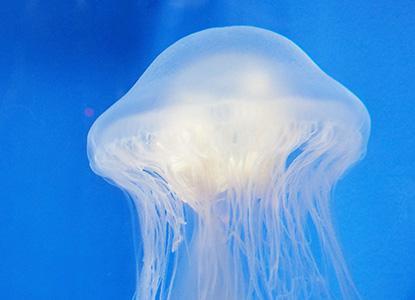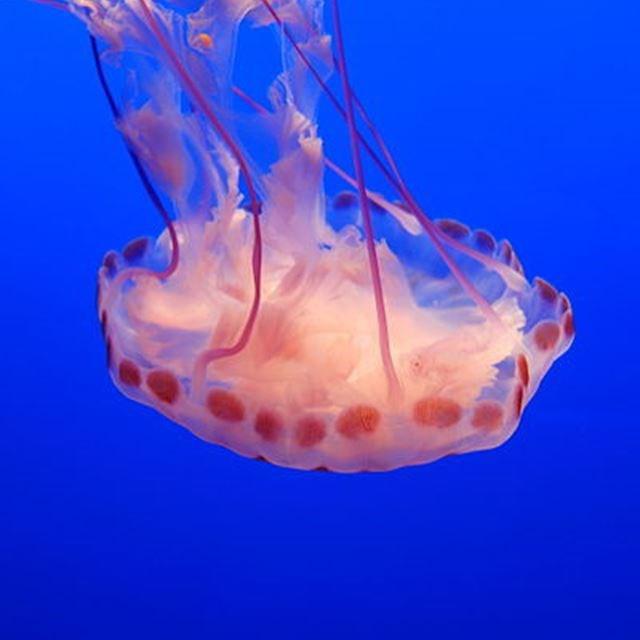The first image is the image on the left, the second image is the image on the right. Evaluate the accuracy of this statement regarding the images: "There are two jellyfish in one image and one in the other image.". Is it true? Answer yes or no. No. The first image is the image on the left, the second image is the image on the right. Considering the images on both sides, is "The left image contains one jellyfish with a mushroom shaped cap facing rightside up and stringlike tentacles trailing down from it, and the right image includes a jellyfish with red-orange dots around the rim of its cap." valid? Answer yes or no. Yes. 